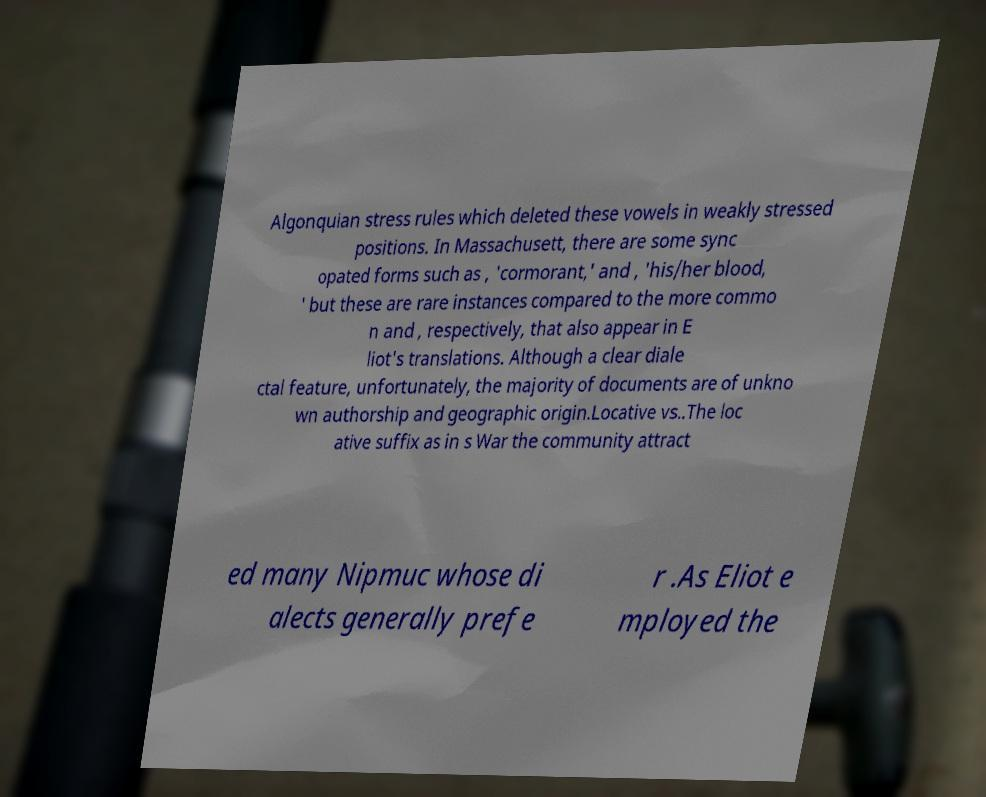Could you extract and type out the text from this image? Algonquian stress rules which deleted these vowels in weakly stressed positions. In Massachusett, there are some sync opated forms such as , 'cormorant,' and , 'his/her blood, ' but these are rare instances compared to the more commo n and , respectively, that also appear in E liot's translations. Although a clear diale ctal feature, unfortunately, the majority of documents are of unkno wn authorship and geographic origin.Locative vs..The loc ative suffix as in s War the community attract ed many Nipmuc whose di alects generally prefe r .As Eliot e mployed the 